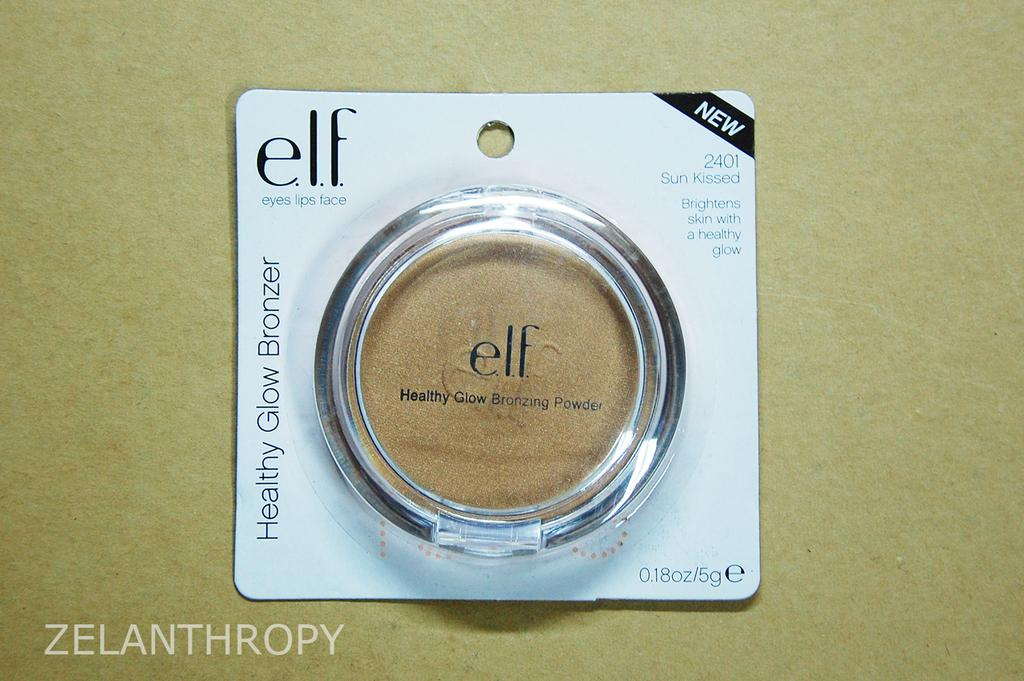<image>
Relay a brief, clear account of the picture shown. A small round.Elf brand makeup container with makeup included 